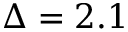<formula> <loc_0><loc_0><loc_500><loc_500>\Delta = 2 . 1</formula> 